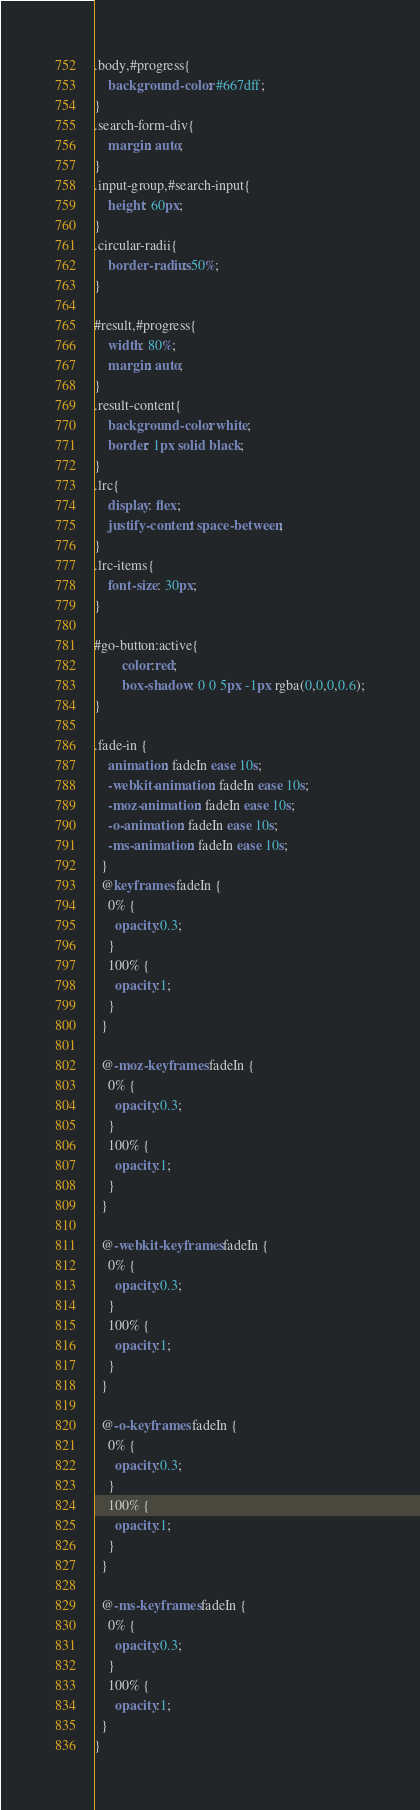Convert code to text. <code><loc_0><loc_0><loc_500><loc_500><_CSS_>.body,#progress{
    background-color: #667dff;
}
.search-form-div{
    margin: auto;
}
.input-group,#search-input{
    height: 60px;
}
.circular-radii{
    border-radius: 50%;
}

#result,#progress{
    width: 80%;
    margin: auto;
}
.result-content{
    background-color: white;
    border: 1px solid black;
}
.lrc{
    display: flex;
    justify-content: space-between;
}
.lrc-items{
    font-size: 30px;
}

#go-button:active{
        color:red;
        box-shadow: 0 0 5px -1px rgba(0,0,0,0.6);
}

.fade-in {
    animation: fadeIn ease 10s;
    -webkit-animation: fadeIn ease 10s;
    -moz-animation: fadeIn ease 10s;
    -o-animation: fadeIn ease 10s;
    -ms-animation: fadeIn ease 10s;
  }
  @keyframes fadeIn {
    0% {
      opacity:0.3;
    }
    100% {
      opacity:1;
    }
  }
  
  @-moz-keyframes fadeIn {
    0% {
      opacity:0.3;
    }
    100% {
      opacity:1;
    }
  }
  
  @-webkit-keyframes fadeIn {
    0% {
      opacity:0.3;
    }
    100% {
      opacity:1;
    }
  }
  
  @-o-keyframes fadeIn {
    0% {
      opacity:0.3;
    }
    100% {
      opacity:1;
    }
  }
  
  @-ms-keyframes fadeIn {
    0% {
      opacity:0.3;
    }
    100% {
      opacity:1;
  }
}
</code> 